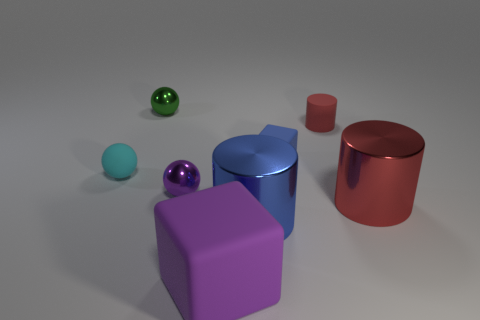Add 1 brown rubber blocks. How many objects exist? 9 Subtract all balls. How many objects are left? 5 Add 1 large shiny objects. How many large shiny objects exist? 3 Subtract 1 purple balls. How many objects are left? 7 Subtract all large purple metallic things. Subtract all cylinders. How many objects are left? 5 Add 5 big purple rubber cubes. How many big purple rubber cubes are left? 6 